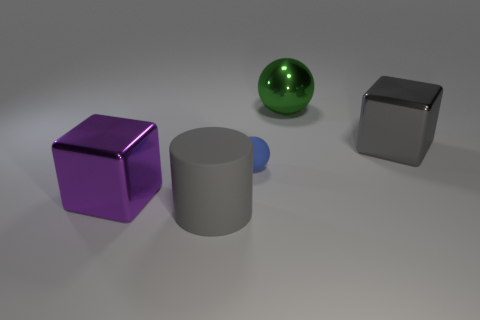Are there any green spheres in front of the cylinder?
Your answer should be very brief. No. Is the number of small cyan things greater than the number of purple blocks?
Offer a very short reply. No. What color is the metal thing behind the block behind the metal thing that is left of the cylinder?
Your answer should be compact. Green. The block that is made of the same material as the big purple object is what color?
Give a very brief answer. Gray. Is there anything else that is the same size as the green metal object?
Offer a terse response. Yes. How many things are either big gray cylinders that are left of the tiny blue object or rubber things that are behind the large matte cylinder?
Make the answer very short. 2. Do the gray thing to the left of the big gray metallic object and the metal cube that is to the right of the purple object have the same size?
Your response must be concise. Yes. What color is the other large metal thing that is the same shape as the big purple metallic object?
Give a very brief answer. Gray. Are there any other things that have the same shape as the large gray metallic object?
Keep it short and to the point. Yes. Are there more gray cylinders that are behind the green sphere than large purple shiny cubes that are to the left of the purple metallic cube?
Keep it short and to the point. No. 